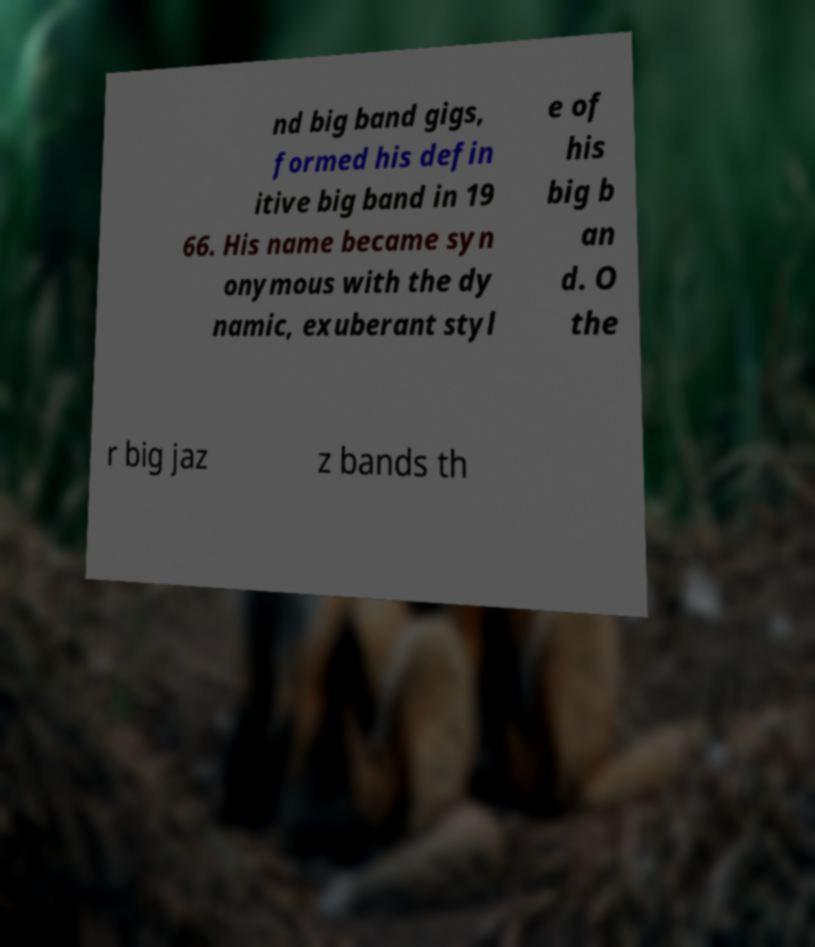What messages or text are displayed in this image? I need them in a readable, typed format. nd big band gigs, formed his defin itive big band in 19 66. His name became syn onymous with the dy namic, exuberant styl e of his big b an d. O the r big jaz z bands th 